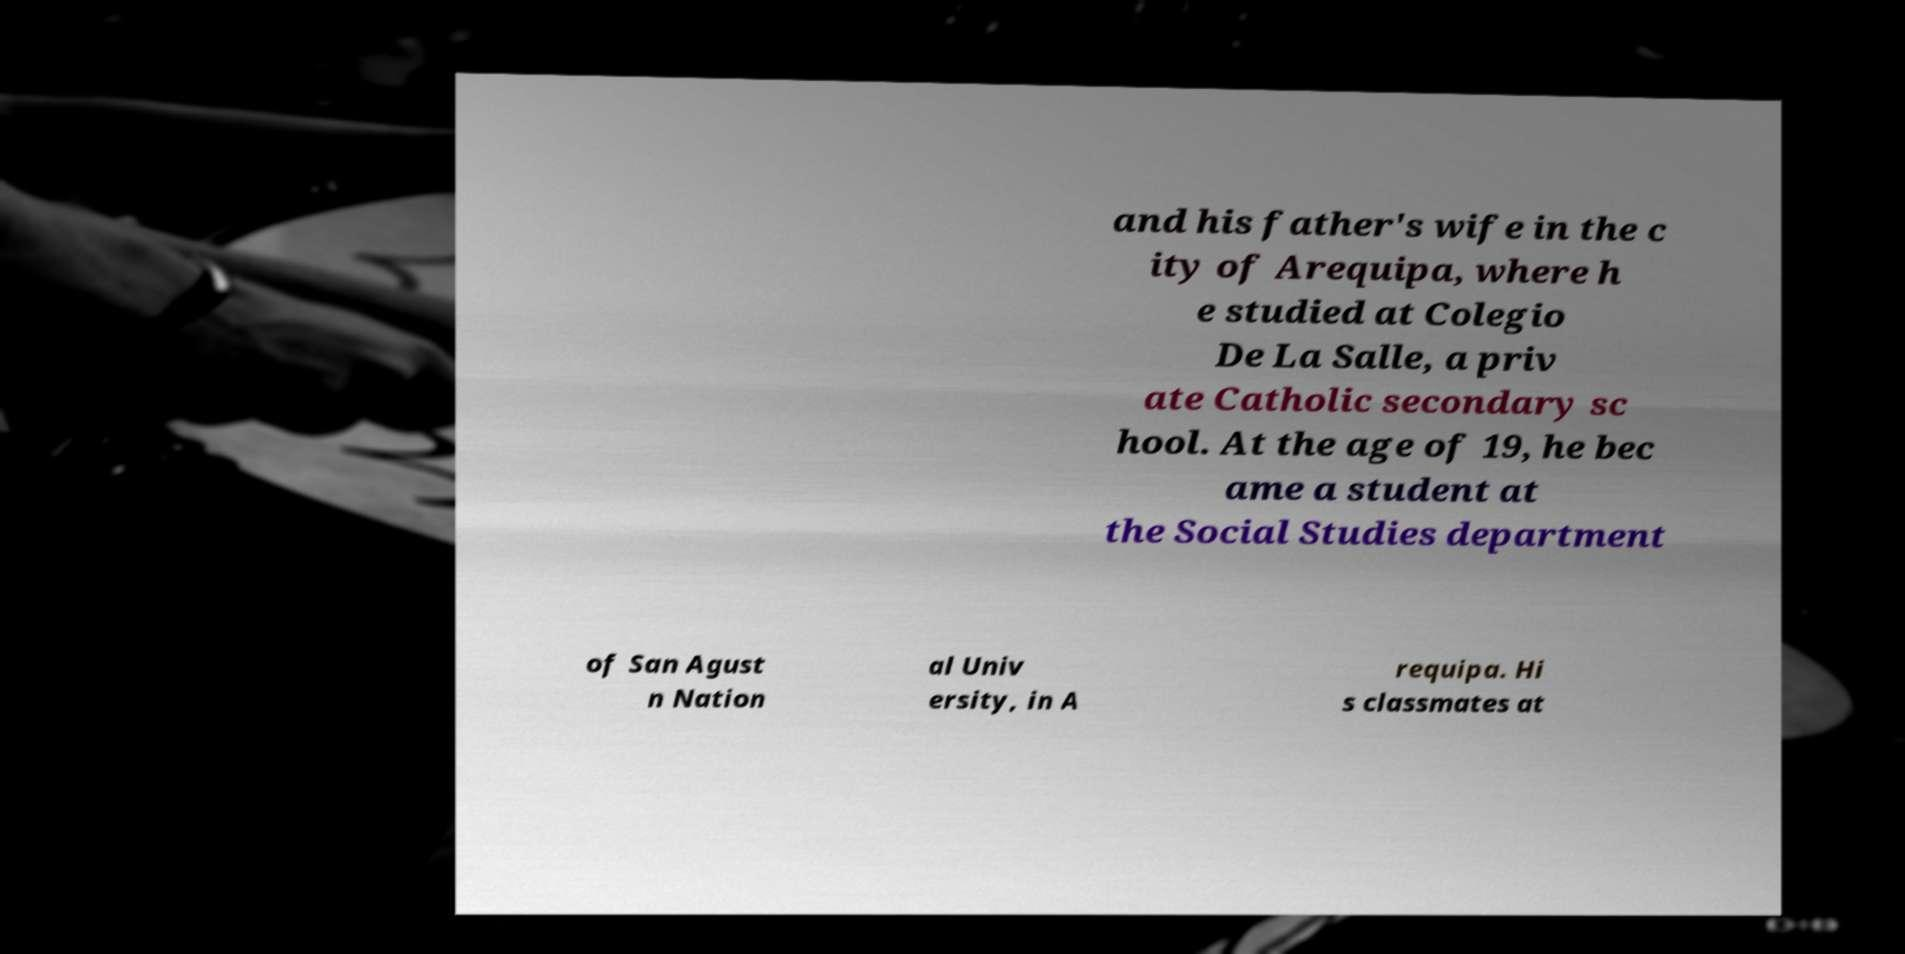What messages or text are displayed in this image? I need them in a readable, typed format. and his father's wife in the c ity of Arequipa, where h e studied at Colegio De La Salle, a priv ate Catholic secondary sc hool. At the age of 19, he bec ame a student at the Social Studies department of San Agust n Nation al Univ ersity, in A requipa. Hi s classmates at 